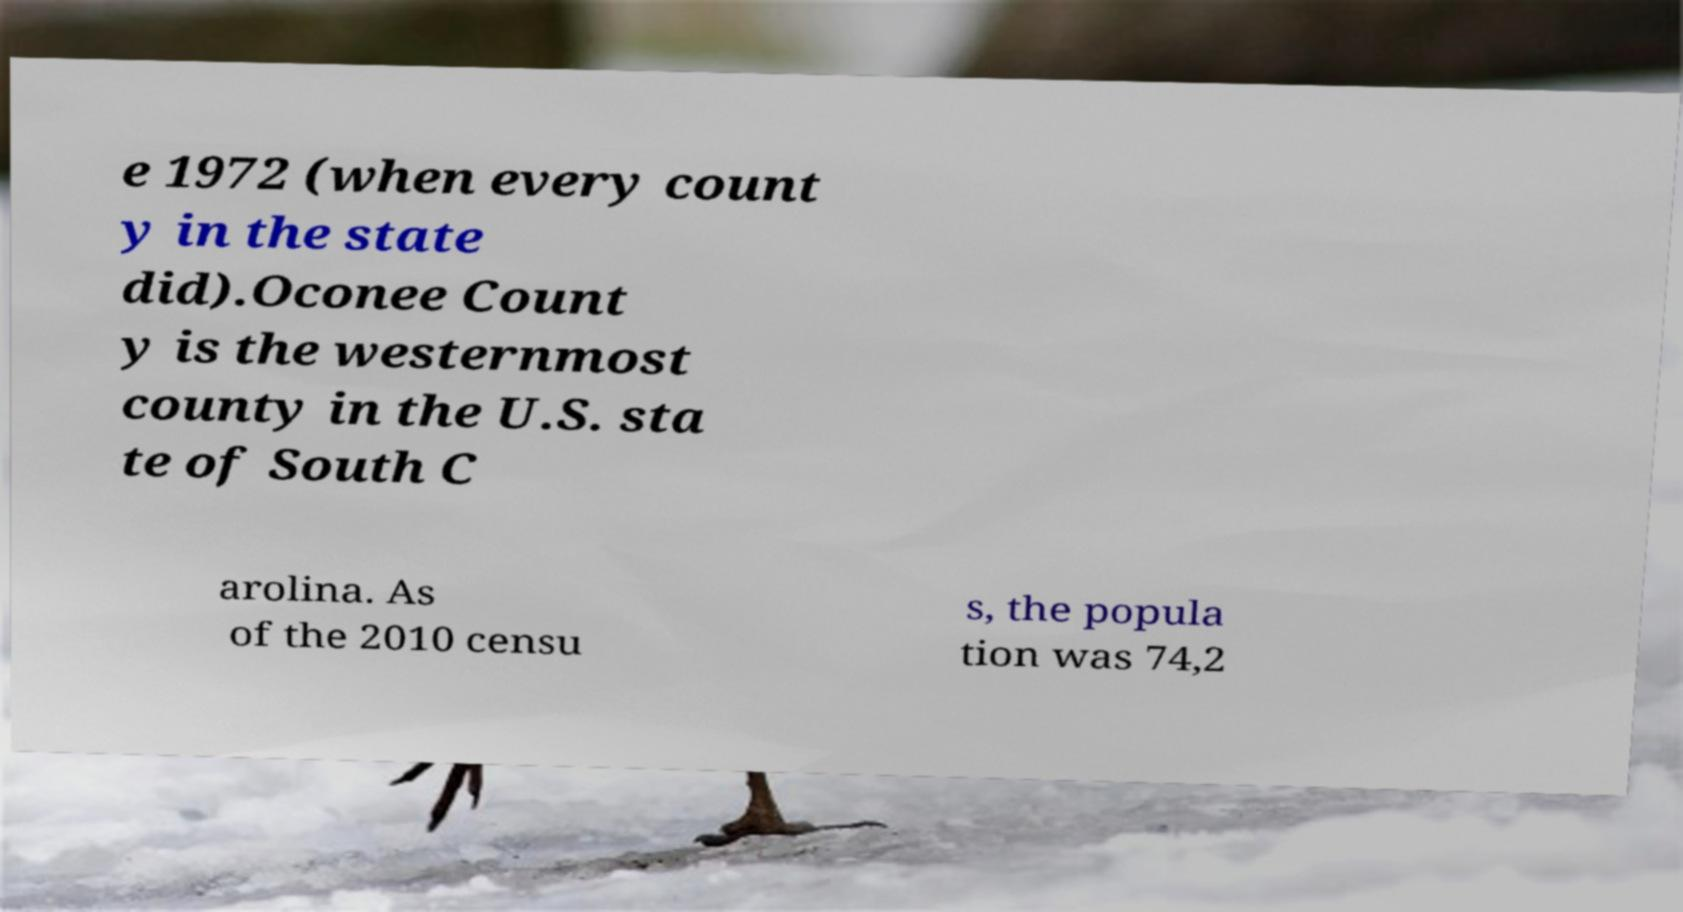For documentation purposes, I need the text within this image transcribed. Could you provide that? e 1972 (when every count y in the state did).Oconee Count y is the westernmost county in the U.S. sta te of South C arolina. As of the 2010 censu s, the popula tion was 74,2 